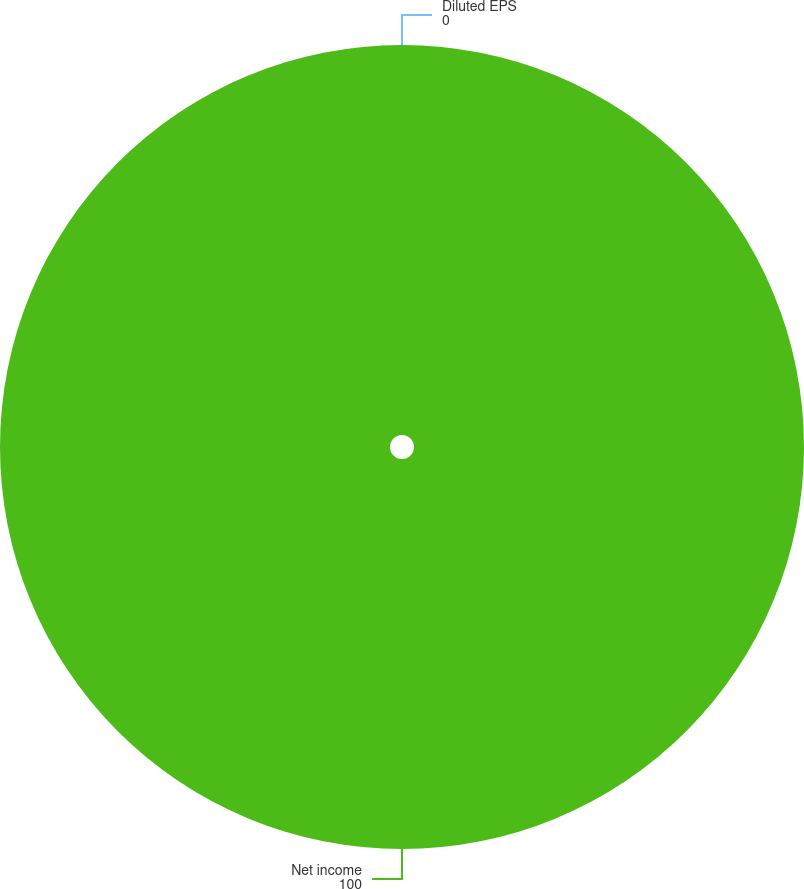Convert chart to OTSL. <chart><loc_0><loc_0><loc_500><loc_500><pie_chart><fcel>Net income<fcel>Diluted EPS<nl><fcel>100.0%<fcel>0.0%<nl></chart> 